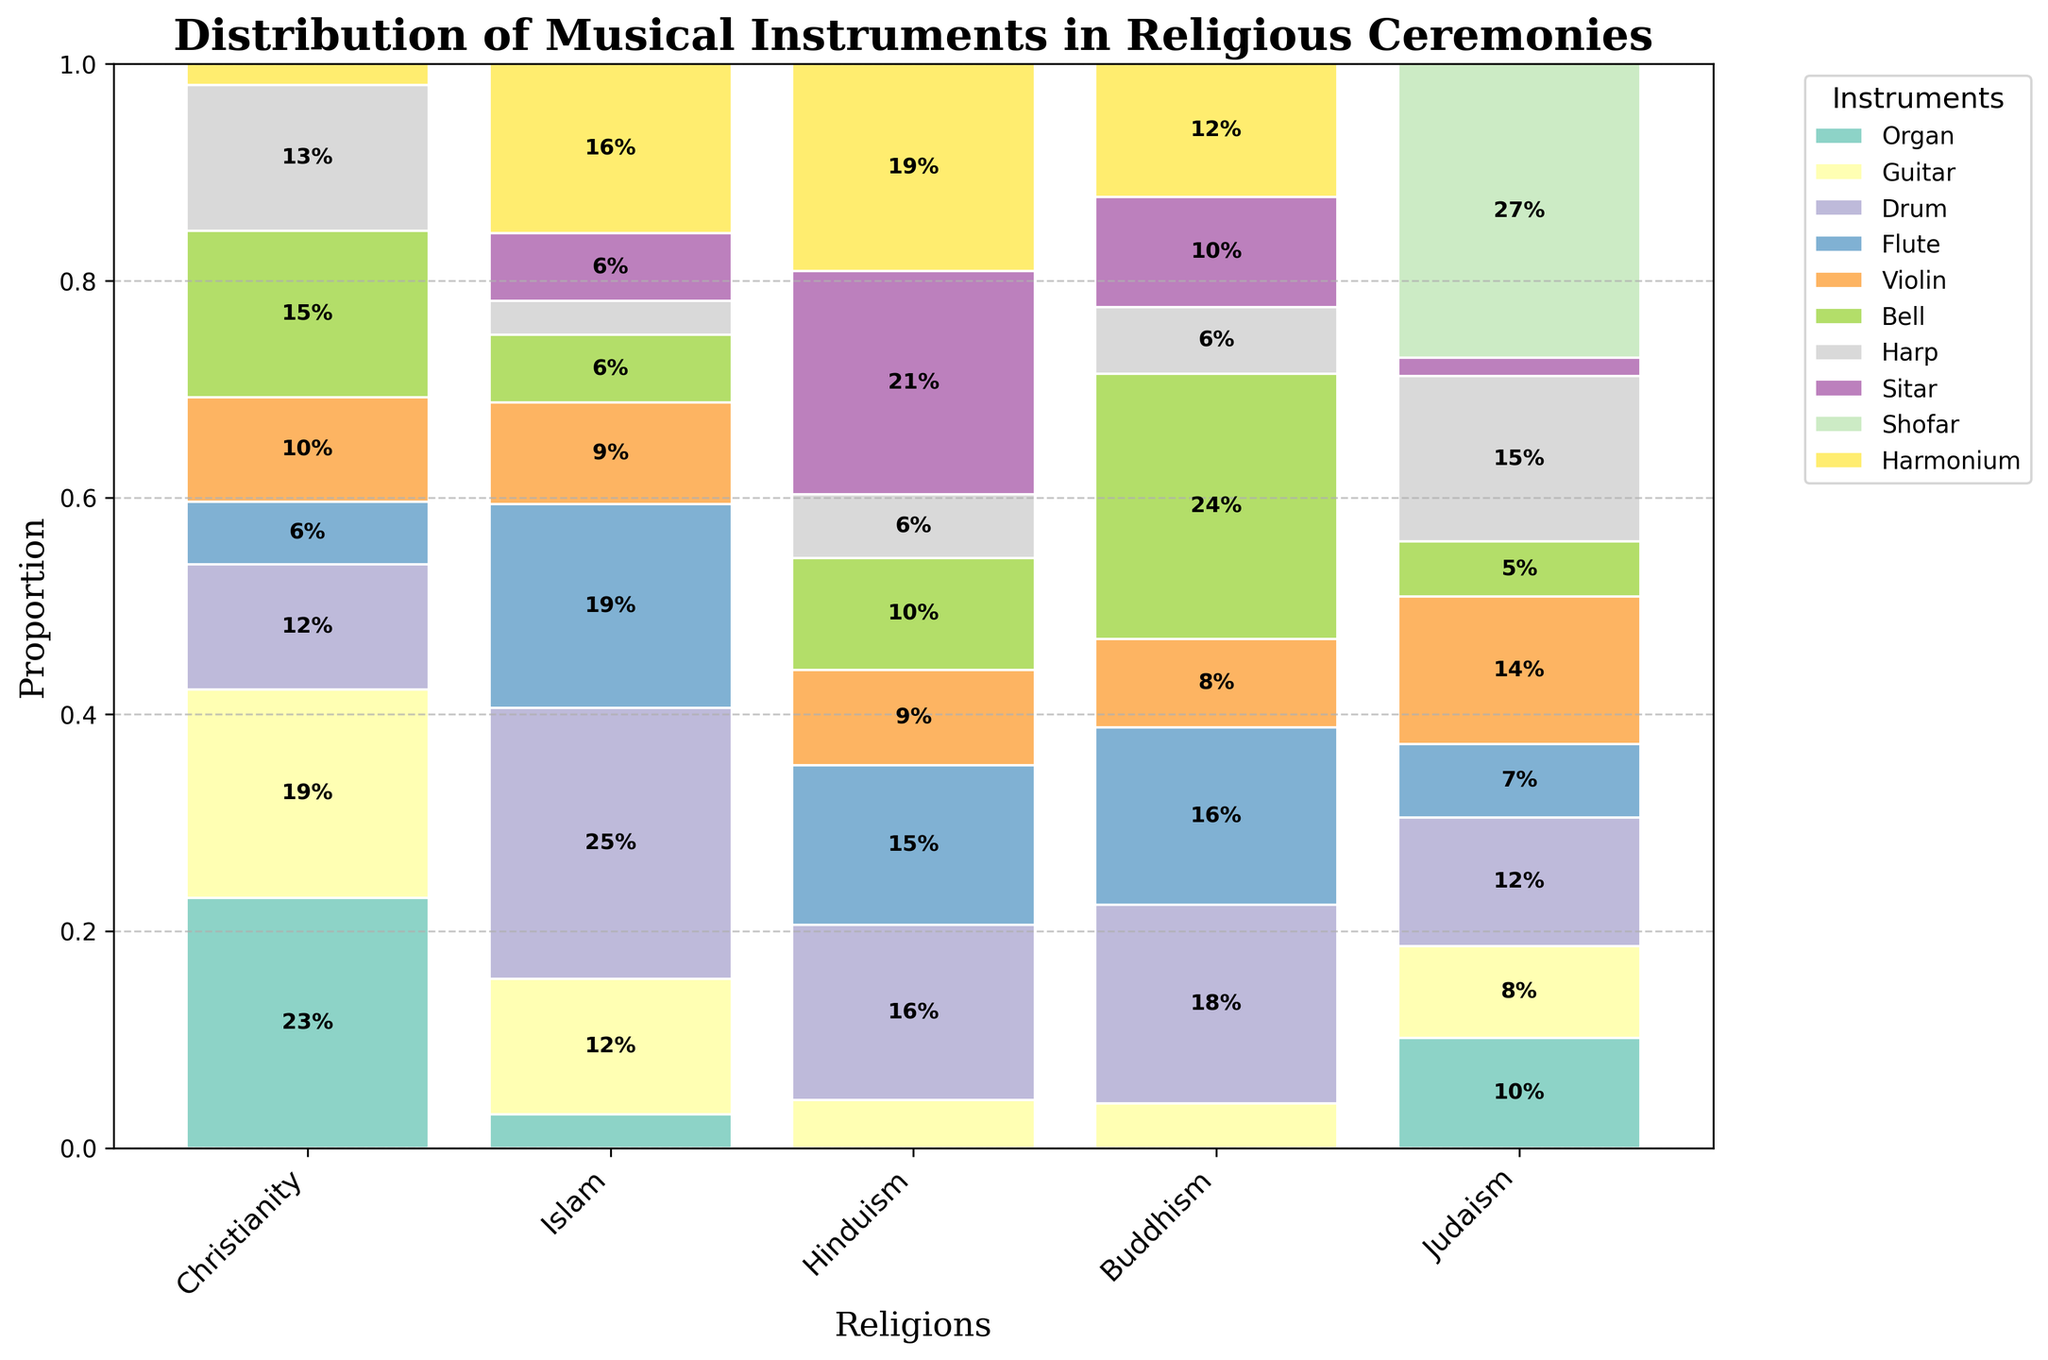What's the title of the figure? The title of the figure is typically shown at the top. In this case, it reads "Distribution of Musical Instruments in Religious Ceremonies".
Answer: Distribution of Musical Instruments in Religious Ceremonies How many religions are represented in the plot? The plot's x-axis displays the different religions being represented. Count the number of labels on the x-axis to find the answer.
Answer: 5 Which instrument is used exclusively in one religion? Examine the segments of the plot to find an instrument that appears in only one category. The segment for the Shofar is only present in Judaism.
Answer: Shofar Which two instruments have the highest proportion in Buddhist ceremonies? Identify the tallest segments in the Buddhism column. The largest segments are for the Bell and the Drum.
Answer: Bell and Drum What's the total proportion of usage for the Guitar in Islam and Buddhism? Look at the height of the Guitar segments for both Islam and Buddhism. Add the proportions of Guitar usage in both religions: 20% (Islam) + 10% (Buddhism) = 30%.
Answer: 30% Between the Organ and the Violin, which is more commonly used in Christianity? Compare the heights of the Organ and Violin segments in the Christianity column. The Organ segment is taller than the Violin segment.
Answer: Organ What percentage of Hindu ceremonies use the Sitar? Find the Sitar segment within the Hinduism column and read its proportion.
Answer: 70% How does the proportion of the Flute compare between Hinduism and Judaism? Compare the heights (proportions) of the Flute segments in both Hinduism and Judaism. The Flute segment is higher in Hinduism than in Judaism.
Answer: Higher in Hinduism Which religion uses the Harmonium the most? Look at the Harmonium segment across all religions. The tallest segment is in Hinduism.
Answer: Hinduism Do any instruments have a usage proportion below 10% in Christianity? If so, which ones? Check the Christianity column for any segments that are less than 10% tall. The Harmonium is the only one below 10%.
Answer: Harmonium 